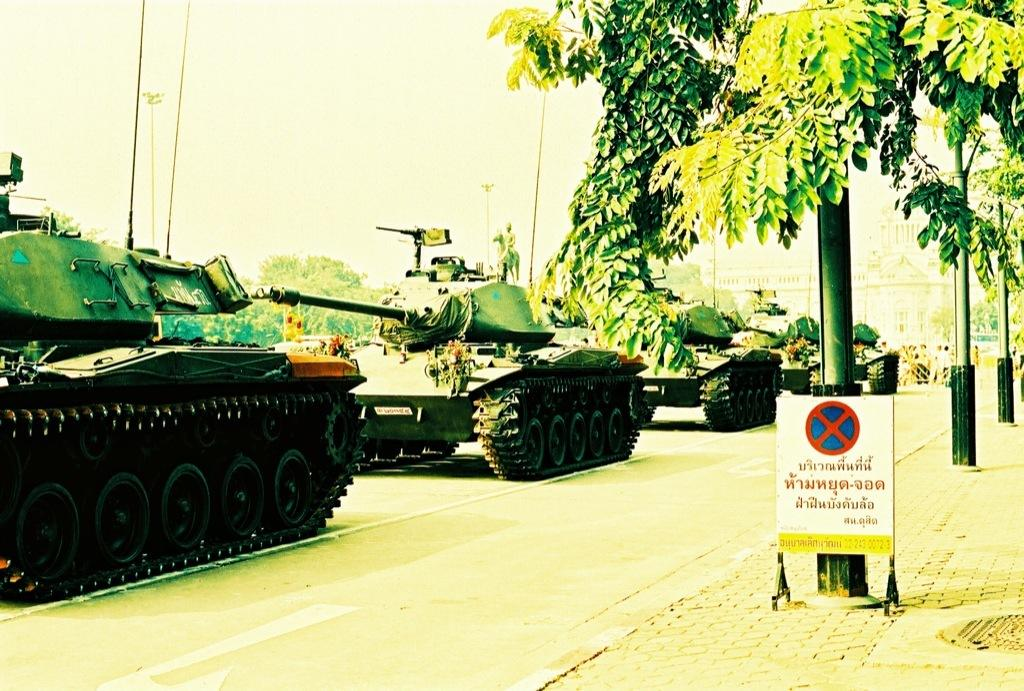What type of vehicles are present in the image? There are military tankers in the image. What are the military tankers doing in the image? The military tankers are moving on the road. What can be seen on the right side of the image? There are poles and trees on the right side of the image. What is visible in the background of the image? The sky is visible in the background of the image. Where is the faucet located in the image? There is no faucet present in the image. How many feet are visible in the image? There are no feet visible in the image. 